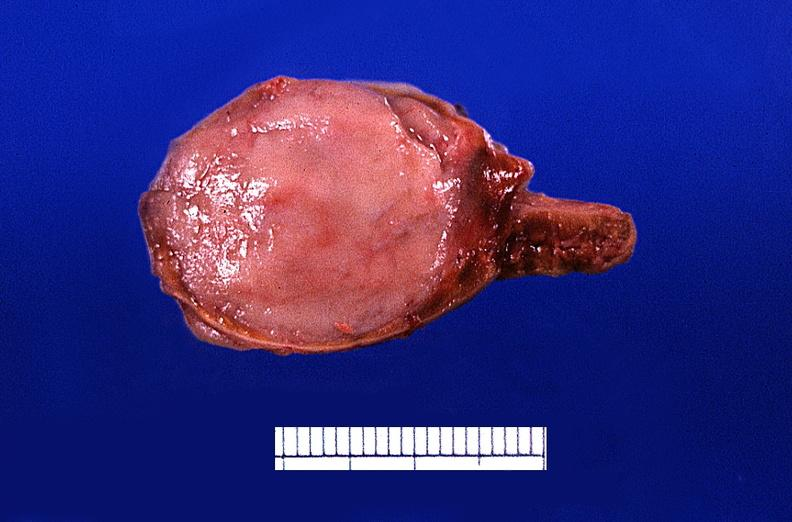where does this belong to?
Answer the question using a single word or phrase. Endocrine system 